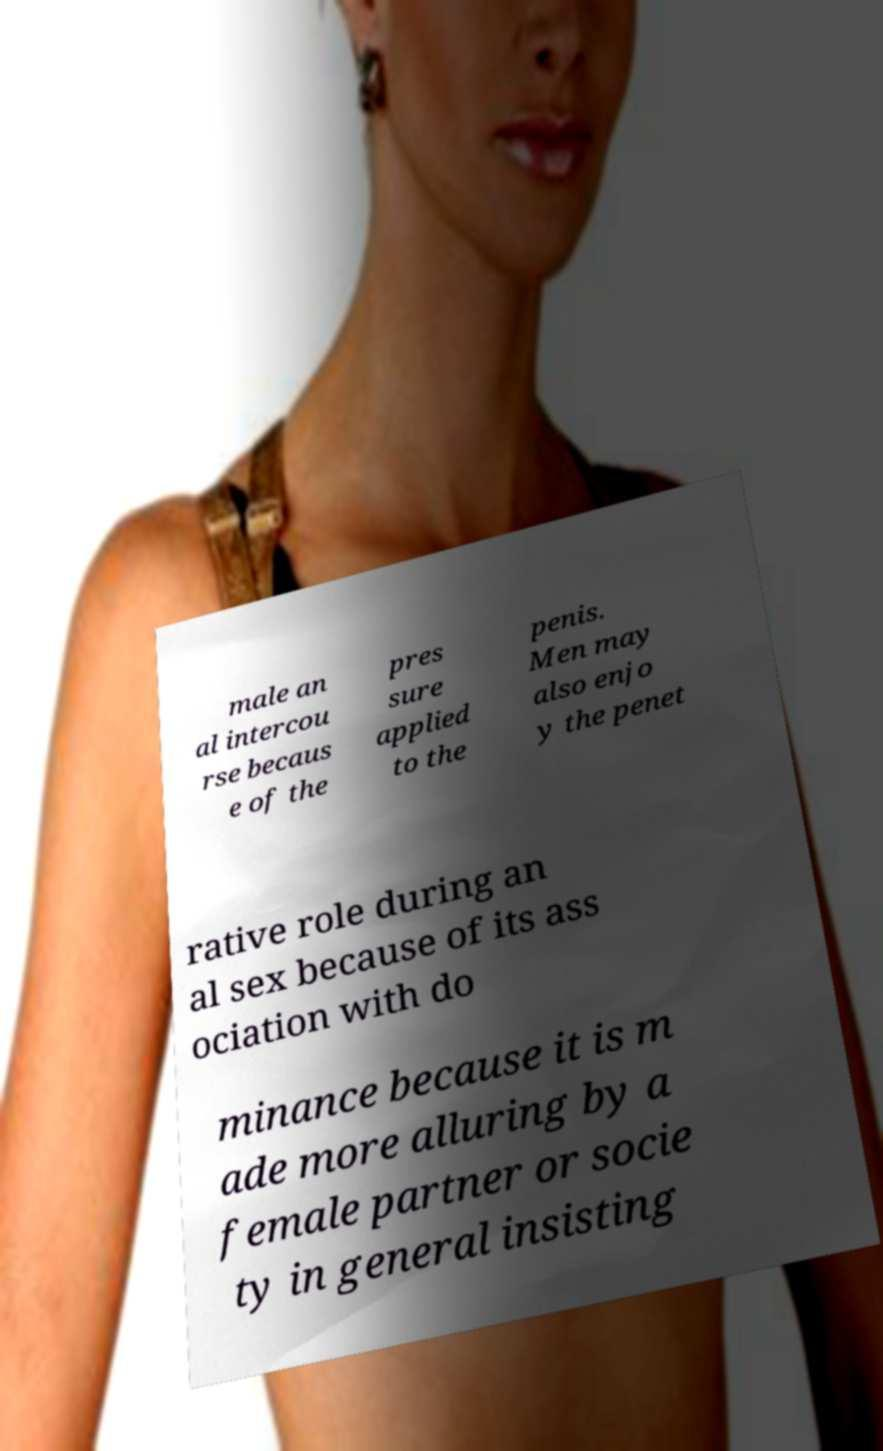I need the written content from this picture converted into text. Can you do that? male an al intercou rse becaus e of the pres sure applied to the penis. Men may also enjo y the penet rative role during an al sex because of its ass ociation with do minance because it is m ade more alluring by a female partner or socie ty in general insisting 